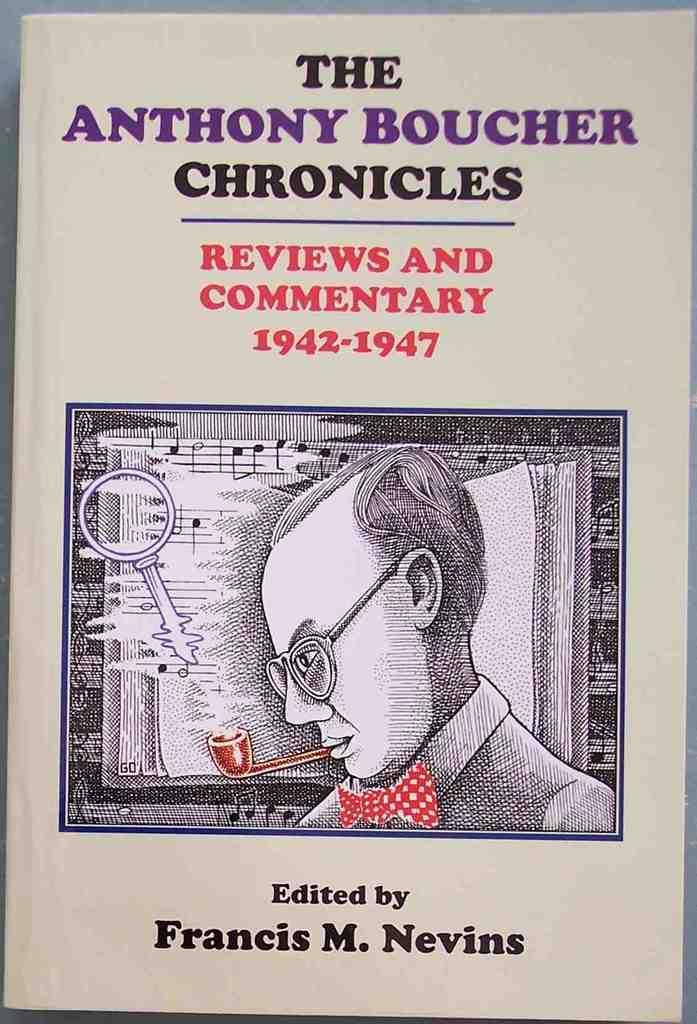Provide a one-sentence caption for the provided image. Francis Nevins creates a book about Anthony Boucher's life, spanning five years. 